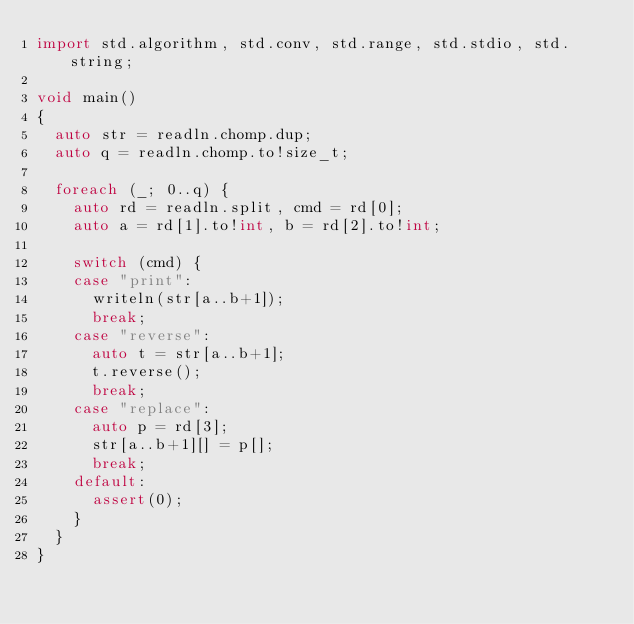<code> <loc_0><loc_0><loc_500><loc_500><_D_>import std.algorithm, std.conv, std.range, std.stdio, std.string;

void main()
{
  auto str = readln.chomp.dup;
  auto q = readln.chomp.to!size_t;

  foreach (_; 0..q) {
    auto rd = readln.split, cmd = rd[0];
    auto a = rd[1].to!int, b = rd[2].to!int;

    switch (cmd) {
    case "print":
      writeln(str[a..b+1]);
      break;
    case "reverse":
      auto t = str[a..b+1];
      t.reverse();
      break;
    case "replace":
      auto p = rd[3];
      str[a..b+1][] = p[];
      break;
    default:
      assert(0);
    }
  }
}</code> 